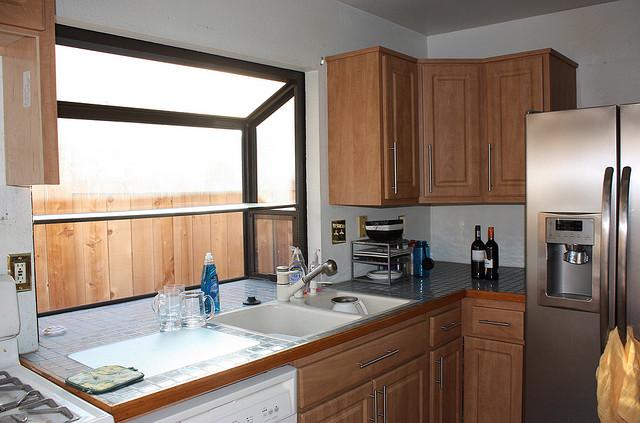What color is the dish liquid?
Be succinct. Blue. How many doors are in that picture, cabinet or otherwise?
Quick response, please. 10. Who made the dish soap that color?
Quick response, please. Dawn. Is there a stainless steel appliance in the picture?
Short answer required. Yes. 